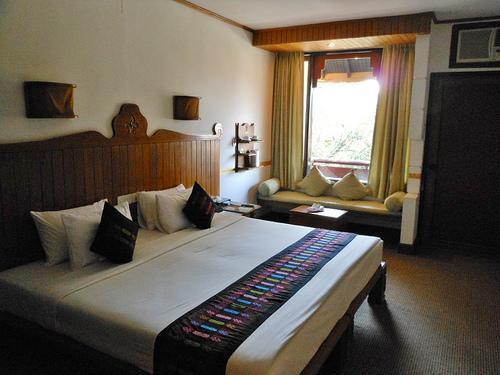How many beds are picture?
Give a very brief answer. 1. 